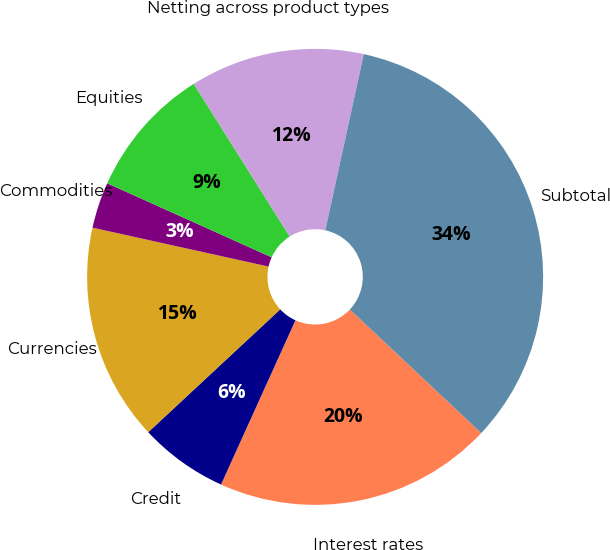<chart> <loc_0><loc_0><loc_500><loc_500><pie_chart><fcel>Interest rates<fcel>Credit<fcel>Currencies<fcel>Commodities<fcel>Equities<fcel>Netting across product types<fcel>Subtotal<nl><fcel>19.76%<fcel>6.3%<fcel>15.39%<fcel>3.27%<fcel>9.33%<fcel>12.36%<fcel>33.58%<nl></chart> 